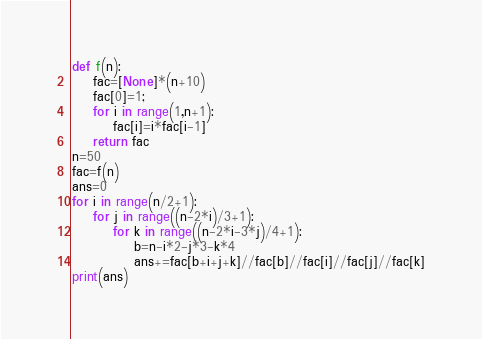<code> <loc_0><loc_0><loc_500><loc_500><_Python_>def f(n):
	fac=[None]*(n+10)
	fac[0]=1;
	for i in range(1,n+1):
		fac[i]=i*fac[i-1]
	return fac
n=50
fac=f(n)
ans=0
for i in range(n/2+1):
	for j in range((n-2*i)/3+1):
		for k in range((n-2*i-3*j)/4+1):
			b=n-i*2-j*3-k*4
			ans+=fac[b+i+j+k]//fac[b]//fac[i]//fac[j]//fac[k]
print(ans)
</code> 